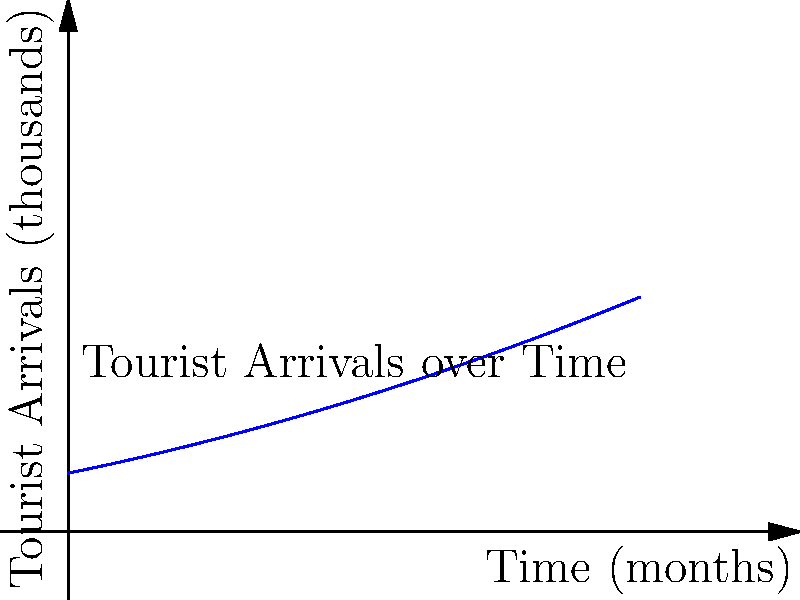As a security personnel monitoring tourist arrivals, you're tasked with analyzing the rate of change in tourist numbers. The graph shows tourist arrivals over time. What is the instantaneous rate of change in tourist arrivals after 5 months? To find the instantaneous rate of change after 5 months, we need to calculate the derivative of the function at x = 5. Let's approach this step-by-step:

1. The graph appears to represent a quadratic function. We can estimate it as:
   $f(x) = 50 + 10x + 0.5x^2$

2. To find the rate of change, we need to differentiate this function:
   $f'(x) = 10 + x$

3. Now, we need to evaluate this derivative at x = 5:
   $f'(5) = 10 + 5 = 15$

4. Interpreting the result:
   The rate of change after 5 months is 15 thousand tourists per month.

5. In the context of security and cultural awareness:
   This rapid increase in tourist arrivals (15,000 per month at this point) might require increased security measures and cultural orientation programs to ensure smooth integration of visitors with local customs and traditions.
Answer: 15 thousand tourists per month 